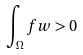<formula> <loc_0><loc_0><loc_500><loc_500>\int _ { \Omega } f w > 0</formula> 